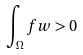<formula> <loc_0><loc_0><loc_500><loc_500>\int _ { \Omega } f w > 0</formula> 